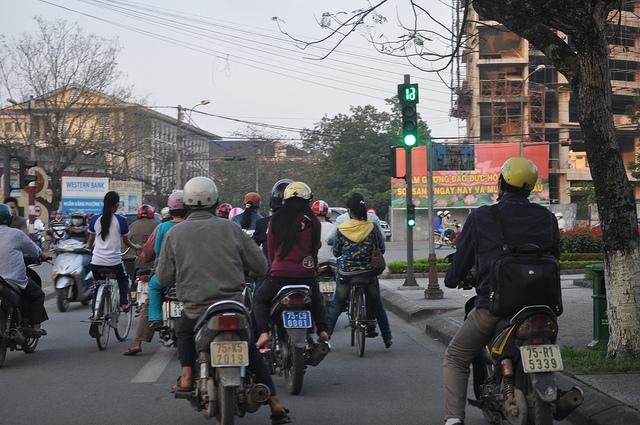What country is this street scene likely part of? vietnam 